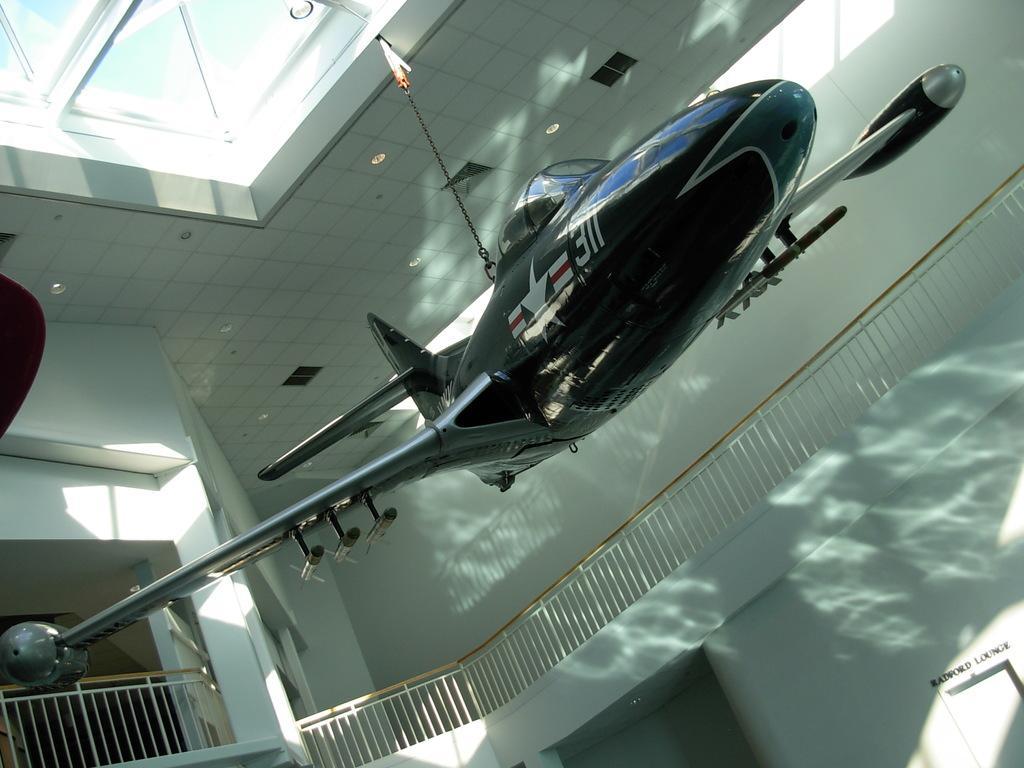How would you summarize this image in a sentence or two? In the image we can see there is an aircraft hanging from the top and there are iron railings. On the top there is a window. 